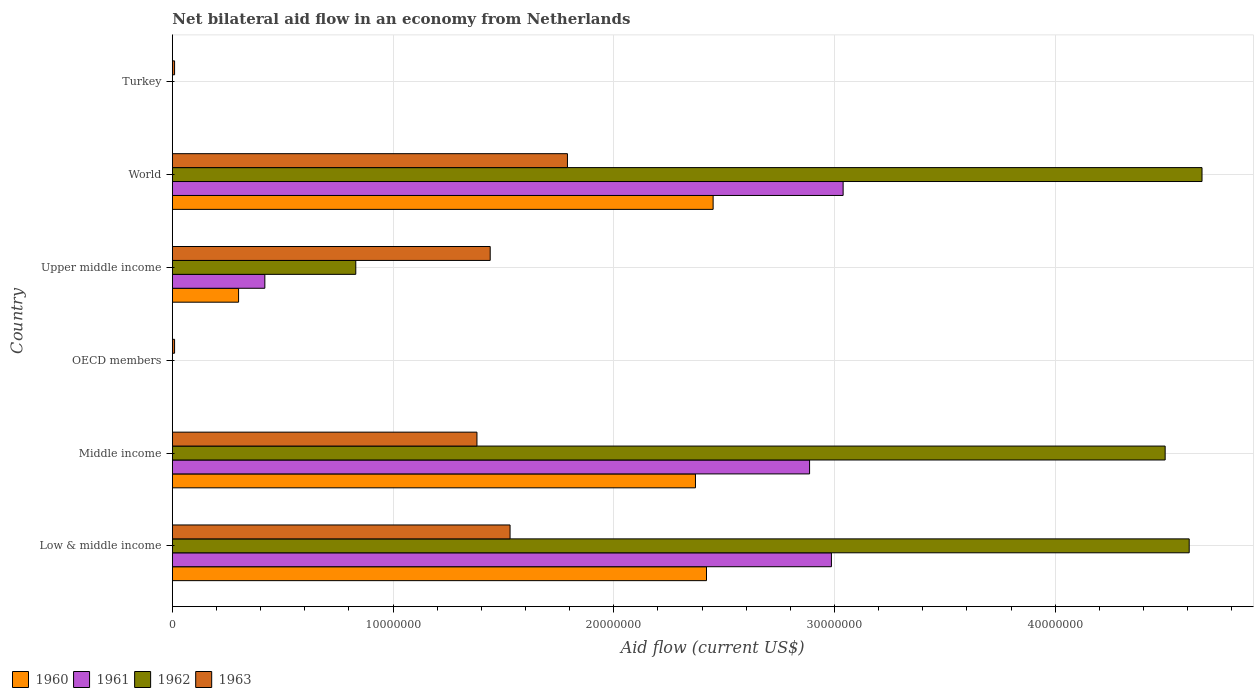How many different coloured bars are there?
Keep it short and to the point. 4. How many bars are there on the 2nd tick from the top?
Offer a very short reply. 4. How many bars are there on the 6th tick from the bottom?
Give a very brief answer. 1. What is the label of the 1st group of bars from the top?
Offer a terse response. Turkey. In how many cases, is the number of bars for a given country not equal to the number of legend labels?
Make the answer very short. 2. What is the net bilateral aid flow in 1962 in Middle income?
Give a very brief answer. 4.50e+07. Across all countries, what is the maximum net bilateral aid flow in 1960?
Provide a short and direct response. 2.45e+07. Across all countries, what is the minimum net bilateral aid flow in 1963?
Your answer should be compact. 1.00e+05. What is the total net bilateral aid flow in 1960 in the graph?
Provide a short and direct response. 7.54e+07. What is the difference between the net bilateral aid flow in 1962 in Middle income and the net bilateral aid flow in 1963 in World?
Your response must be concise. 2.71e+07. What is the average net bilateral aid flow in 1961 per country?
Your response must be concise. 1.56e+07. What is the difference between the net bilateral aid flow in 1961 and net bilateral aid flow in 1962 in World?
Your response must be concise. -1.63e+07. What is the ratio of the net bilateral aid flow in 1961 in Low & middle income to that in Middle income?
Ensure brevity in your answer.  1.03. Is the net bilateral aid flow in 1960 in Middle income less than that in Upper middle income?
Ensure brevity in your answer.  No. What is the difference between the highest and the lowest net bilateral aid flow in 1961?
Provide a succinct answer. 3.04e+07. In how many countries, is the net bilateral aid flow in 1960 greater than the average net bilateral aid flow in 1960 taken over all countries?
Your answer should be compact. 3. Is it the case that in every country, the sum of the net bilateral aid flow in 1963 and net bilateral aid flow in 1961 is greater than the net bilateral aid flow in 1962?
Your answer should be compact. No. How many bars are there?
Ensure brevity in your answer.  18. Are all the bars in the graph horizontal?
Keep it short and to the point. Yes. What is the difference between two consecutive major ticks on the X-axis?
Your response must be concise. 1.00e+07. Are the values on the major ticks of X-axis written in scientific E-notation?
Provide a short and direct response. No. What is the title of the graph?
Your response must be concise. Net bilateral aid flow in an economy from Netherlands. Does "1994" appear as one of the legend labels in the graph?
Offer a terse response. No. What is the label or title of the Y-axis?
Your answer should be very brief. Country. What is the Aid flow (current US$) in 1960 in Low & middle income?
Offer a terse response. 2.42e+07. What is the Aid flow (current US$) in 1961 in Low & middle income?
Keep it short and to the point. 2.99e+07. What is the Aid flow (current US$) of 1962 in Low & middle income?
Offer a very short reply. 4.61e+07. What is the Aid flow (current US$) of 1963 in Low & middle income?
Offer a terse response. 1.53e+07. What is the Aid flow (current US$) of 1960 in Middle income?
Make the answer very short. 2.37e+07. What is the Aid flow (current US$) of 1961 in Middle income?
Offer a terse response. 2.89e+07. What is the Aid flow (current US$) of 1962 in Middle income?
Provide a succinct answer. 4.50e+07. What is the Aid flow (current US$) of 1963 in Middle income?
Your response must be concise. 1.38e+07. What is the Aid flow (current US$) of 1963 in OECD members?
Offer a terse response. 1.00e+05. What is the Aid flow (current US$) of 1961 in Upper middle income?
Make the answer very short. 4.19e+06. What is the Aid flow (current US$) in 1962 in Upper middle income?
Provide a short and direct response. 8.31e+06. What is the Aid flow (current US$) in 1963 in Upper middle income?
Ensure brevity in your answer.  1.44e+07. What is the Aid flow (current US$) in 1960 in World?
Provide a succinct answer. 2.45e+07. What is the Aid flow (current US$) of 1961 in World?
Your answer should be compact. 3.04e+07. What is the Aid flow (current US$) in 1962 in World?
Offer a very short reply. 4.66e+07. What is the Aid flow (current US$) of 1963 in World?
Provide a succinct answer. 1.79e+07. What is the Aid flow (current US$) of 1960 in Turkey?
Give a very brief answer. 0. What is the Aid flow (current US$) of 1963 in Turkey?
Your response must be concise. 1.00e+05. Across all countries, what is the maximum Aid flow (current US$) in 1960?
Give a very brief answer. 2.45e+07. Across all countries, what is the maximum Aid flow (current US$) of 1961?
Give a very brief answer. 3.04e+07. Across all countries, what is the maximum Aid flow (current US$) in 1962?
Offer a terse response. 4.66e+07. Across all countries, what is the maximum Aid flow (current US$) in 1963?
Make the answer very short. 1.79e+07. Across all countries, what is the minimum Aid flow (current US$) in 1961?
Ensure brevity in your answer.  0. Across all countries, what is the minimum Aid flow (current US$) in 1962?
Offer a very short reply. 0. What is the total Aid flow (current US$) in 1960 in the graph?
Your response must be concise. 7.54e+07. What is the total Aid flow (current US$) of 1961 in the graph?
Make the answer very short. 9.33e+07. What is the total Aid flow (current US$) of 1962 in the graph?
Keep it short and to the point. 1.46e+08. What is the total Aid flow (current US$) of 1963 in the graph?
Provide a succinct answer. 6.16e+07. What is the difference between the Aid flow (current US$) in 1960 in Low & middle income and that in Middle income?
Provide a short and direct response. 5.00e+05. What is the difference between the Aid flow (current US$) of 1961 in Low & middle income and that in Middle income?
Provide a short and direct response. 9.90e+05. What is the difference between the Aid flow (current US$) in 1962 in Low & middle income and that in Middle income?
Your response must be concise. 1.09e+06. What is the difference between the Aid flow (current US$) of 1963 in Low & middle income and that in Middle income?
Make the answer very short. 1.50e+06. What is the difference between the Aid flow (current US$) in 1963 in Low & middle income and that in OECD members?
Your response must be concise. 1.52e+07. What is the difference between the Aid flow (current US$) of 1960 in Low & middle income and that in Upper middle income?
Your answer should be compact. 2.12e+07. What is the difference between the Aid flow (current US$) in 1961 in Low & middle income and that in Upper middle income?
Keep it short and to the point. 2.57e+07. What is the difference between the Aid flow (current US$) of 1962 in Low & middle income and that in Upper middle income?
Provide a short and direct response. 3.78e+07. What is the difference between the Aid flow (current US$) in 1963 in Low & middle income and that in Upper middle income?
Your answer should be compact. 9.00e+05. What is the difference between the Aid flow (current US$) in 1960 in Low & middle income and that in World?
Your answer should be compact. -3.00e+05. What is the difference between the Aid flow (current US$) of 1961 in Low & middle income and that in World?
Your answer should be very brief. -5.30e+05. What is the difference between the Aid flow (current US$) in 1962 in Low & middle income and that in World?
Offer a terse response. -5.80e+05. What is the difference between the Aid flow (current US$) in 1963 in Low & middle income and that in World?
Your answer should be compact. -2.60e+06. What is the difference between the Aid flow (current US$) of 1963 in Low & middle income and that in Turkey?
Offer a very short reply. 1.52e+07. What is the difference between the Aid flow (current US$) of 1963 in Middle income and that in OECD members?
Offer a terse response. 1.37e+07. What is the difference between the Aid flow (current US$) of 1960 in Middle income and that in Upper middle income?
Your response must be concise. 2.07e+07. What is the difference between the Aid flow (current US$) in 1961 in Middle income and that in Upper middle income?
Your answer should be very brief. 2.47e+07. What is the difference between the Aid flow (current US$) in 1962 in Middle income and that in Upper middle income?
Your answer should be very brief. 3.67e+07. What is the difference between the Aid flow (current US$) in 1963 in Middle income and that in Upper middle income?
Keep it short and to the point. -6.00e+05. What is the difference between the Aid flow (current US$) of 1960 in Middle income and that in World?
Ensure brevity in your answer.  -8.00e+05. What is the difference between the Aid flow (current US$) in 1961 in Middle income and that in World?
Offer a very short reply. -1.52e+06. What is the difference between the Aid flow (current US$) in 1962 in Middle income and that in World?
Ensure brevity in your answer.  -1.67e+06. What is the difference between the Aid flow (current US$) of 1963 in Middle income and that in World?
Your response must be concise. -4.10e+06. What is the difference between the Aid flow (current US$) in 1963 in Middle income and that in Turkey?
Your answer should be compact. 1.37e+07. What is the difference between the Aid flow (current US$) in 1963 in OECD members and that in Upper middle income?
Offer a terse response. -1.43e+07. What is the difference between the Aid flow (current US$) in 1963 in OECD members and that in World?
Ensure brevity in your answer.  -1.78e+07. What is the difference between the Aid flow (current US$) in 1963 in OECD members and that in Turkey?
Your answer should be very brief. 0. What is the difference between the Aid flow (current US$) in 1960 in Upper middle income and that in World?
Keep it short and to the point. -2.15e+07. What is the difference between the Aid flow (current US$) in 1961 in Upper middle income and that in World?
Your answer should be very brief. -2.62e+07. What is the difference between the Aid flow (current US$) of 1962 in Upper middle income and that in World?
Offer a terse response. -3.83e+07. What is the difference between the Aid flow (current US$) in 1963 in Upper middle income and that in World?
Keep it short and to the point. -3.50e+06. What is the difference between the Aid flow (current US$) of 1963 in Upper middle income and that in Turkey?
Provide a succinct answer. 1.43e+07. What is the difference between the Aid flow (current US$) in 1963 in World and that in Turkey?
Give a very brief answer. 1.78e+07. What is the difference between the Aid flow (current US$) of 1960 in Low & middle income and the Aid flow (current US$) of 1961 in Middle income?
Provide a short and direct response. -4.67e+06. What is the difference between the Aid flow (current US$) of 1960 in Low & middle income and the Aid flow (current US$) of 1962 in Middle income?
Ensure brevity in your answer.  -2.08e+07. What is the difference between the Aid flow (current US$) of 1960 in Low & middle income and the Aid flow (current US$) of 1963 in Middle income?
Make the answer very short. 1.04e+07. What is the difference between the Aid flow (current US$) of 1961 in Low & middle income and the Aid flow (current US$) of 1962 in Middle income?
Provide a short and direct response. -1.51e+07. What is the difference between the Aid flow (current US$) in 1961 in Low & middle income and the Aid flow (current US$) in 1963 in Middle income?
Offer a very short reply. 1.61e+07. What is the difference between the Aid flow (current US$) of 1962 in Low & middle income and the Aid flow (current US$) of 1963 in Middle income?
Ensure brevity in your answer.  3.23e+07. What is the difference between the Aid flow (current US$) of 1960 in Low & middle income and the Aid flow (current US$) of 1963 in OECD members?
Make the answer very short. 2.41e+07. What is the difference between the Aid flow (current US$) of 1961 in Low & middle income and the Aid flow (current US$) of 1963 in OECD members?
Offer a terse response. 2.98e+07. What is the difference between the Aid flow (current US$) of 1962 in Low & middle income and the Aid flow (current US$) of 1963 in OECD members?
Keep it short and to the point. 4.60e+07. What is the difference between the Aid flow (current US$) in 1960 in Low & middle income and the Aid flow (current US$) in 1961 in Upper middle income?
Keep it short and to the point. 2.00e+07. What is the difference between the Aid flow (current US$) of 1960 in Low & middle income and the Aid flow (current US$) of 1962 in Upper middle income?
Provide a succinct answer. 1.59e+07. What is the difference between the Aid flow (current US$) in 1960 in Low & middle income and the Aid flow (current US$) in 1963 in Upper middle income?
Ensure brevity in your answer.  9.80e+06. What is the difference between the Aid flow (current US$) in 1961 in Low & middle income and the Aid flow (current US$) in 1962 in Upper middle income?
Your response must be concise. 2.16e+07. What is the difference between the Aid flow (current US$) of 1961 in Low & middle income and the Aid flow (current US$) of 1963 in Upper middle income?
Ensure brevity in your answer.  1.55e+07. What is the difference between the Aid flow (current US$) of 1962 in Low & middle income and the Aid flow (current US$) of 1963 in Upper middle income?
Give a very brief answer. 3.17e+07. What is the difference between the Aid flow (current US$) of 1960 in Low & middle income and the Aid flow (current US$) of 1961 in World?
Keep it short and to the point. -6.19e+06. What is the difference between the Aid flow (current US$) of 1960 in Low & middle income and the Aid flow (current US$) of 1962 in World?
Give a very brief answer. -2.24e+07. What is the difference between the Aid flow (current US$) in 1960 in Low & middle income and the Aid flow (current US$) in 1963 in World?
Make the answer very short. 6.30e+06. What is the difference between the Aid flow (current US$) in 1961 in Low & middle income and the Aid flow (current US$) in 1962 in World?
Your answer should be very brief. -1.68e+07. What is the difference between the Aid flow (current US$) in 1961 in Low & middle income and the Aid flow (current US$) in 1963 in World?
Ensure brevity in your answer.  1.20e+07. What is the difference between the Aid flow (current US$) of 1962 in Low & middle income and the Aid flow (current US$) of 1963 in World?
Provide a short and direct response. 2.82e+07. What is the difference between the Aid flow (current US$) in 1960 in Low & middle income and the Aid flow (current US$) in 1963 in Turkey?
Give a very brief answer. 2.41e+07. What is the difference between the Aid flow (current US$) in 1961 in Low & middle income and the Aid flow (current US$) in 1963 in Turkey?
Give a very brief answer. 2.98e+07. What is the difference between the Aid flow (current US$) in 1962 in Low & middle income and the Aid flow (current US$) in 1963 in Turkey?
Make the answer very short. 4.60e+07. What is the difference between the Aid flow (current US$) of 1960 in Middle income and the Aid flow (current US$) of 1963 in OECD members?
Make the answer very short. 2.36e+07. What is the difference between the Aid flow (current US$) in 1961 in Middle income and the Aid flow (current US$) in 1963 in OECD members?
Offer a terse response. 2.88e+07. What is the difference between the Aid flow (current US$) of 1962 in Middle income and the Aid flow (current US$) of 1963 in OECD members?
Your answer should be compact. 4.49e+07. What is the difference between the Aid flow (current US$) in 1960 in Middle income and the Aid flow (current US$) in 1961 in Upper middle income?
Provide a short and direct response. 1.95e+07. What is the difference between the Aid flow (current US$) of 1960 in Middle income and the Aid flow (current US$) of 1962 in Upper middle income?
Your answer should be compact. 1.54e+07. What is the difference between the Aid flow (current US$) in 1960 in Middle income and the Aid flow (current US$) in 1963 in Upper middle income?
Your answer should be very brief. 9.30e+06. What is the difference between the Aid flow (current US$) in 1961 in Middle income and the Aid flow (current US$) in 1962 in Upper middle income?
Give a very brief answer. 2.06e+07. What is the difference between the Aid flow (current US$) of 1961 in Middle income and the Aid flow (current US$) of 1963 in Upper middle income?
Your response must be concise. 1.45e+07. What is the difference between the Aid flow (current US$) of 1962 in Middle income and the Aid flow (current US$) of 1963 in Upper middle income?
Give a very brief answer. 3.06e+07. What is the difference between the Aid flow (current US$) in 1960 in Middle income and the Aid flow (current US$) in 1961 in World?
Provide a succinct answer. -6.69e+06. What is the difference between the Aid flow (current US$) of 1960 in Middle income and the Aid flow (current US$) of 1962 in World?
Ensure brevity in your answer.  -2.30e+07. What is the difference between the Aid flow (current US$) in 1960 in Middle income and the Aid flow (current US$) in 1963 in World?
Offer a terse response. 5.80e+06. What is the difference between the Aid flow (current US$) in 1961 in Middle income and the Aid flow (current US$) in 1962 in World?
Keep it short and to the point. -1.78e+07. What is the difference between the Aid flow (current US$) in 1961 in Middle income and the Aid flow (current US$) in 1963 in World?
Give a very brief answer. 1.10e+07. What is the difference between the Aid flow (current US$) in 1962 in Middle income and the Aid flow (current US$) in 1963 in World?
Your answer should be very brief. 2.71e+07. What is the difference between the Aid flow (current US$) of 1960 in Middle income and the Aid flow (current US$) of 1963 in Turkey?
Your answer should be compact. 2.36e+07. What is the difference between the Aid flow (current US$) of 1961 in Middle income and the Aid flow (current US$) of 1963 in Turkey?
Your answer should be compact. 2.88e+07. What is the difference between the Aid flow (current US$) of 1962 in Middle income and the Aid flow (current US$) of 1963 in Turkey?
Your response must be concise. 4.49e+07. What is the difference between the Aid flow (current US$) in 1960 in Upper middle income and the Aid flow (current US$) in 1961 in World?
Provide a short and direct response. -2.74e+07. What is the difference between the Aid flow (current US$) of 1960 in Upper middle income and the Aid flow (current US$) of 1962 in World?
Your answer should be compact. -4.36e+07. What is the difference between the Aid flow (current US$) of 1960 in Upper middle income and the Aid flow (current US$) of 1963 in World?
Provide a succinct answer. -1.49e+07. What is the difference between the Aid flow (current US$) of 1961 in Upper middle income and the Aid flow (current US$) of 1962 in World?
Make the answer very short. -4.25e+07. What is the difference between the Aid flow (current US$) in 1961 in Upper middle income and the Aid flow (current US$) in 1963 in World?
Provide a succinct answer. -1.37e+07. What is the difference between the Aid flow (current US$) in 1962 in Upper middle income and the Aid flow (current US$) in 1963 in World?
Your answer should be very brief. -9.59e+06. What is the difference between the Aid flow (current US$) of 1960 in Upper middle income and the Aid flow (current US$) of 1963 in Turkey?
Make the answer very short. 2.90e+06. What is the difference between the Aid flow (current US$) of 1961 in Upper middle income and the Aid flow (current US$) of 1963 in Turkey?
Provide a succinct answer. 4.09e+06. What is the difference between the Aid flow (current US$) in 1962 in Upper middle income and the Aid flow (current US$) in 1963 in Turkey?
Your response must be concise. 8.21e+06. What is the difference between the Aid flow (current US$) of 1960 in World and the Aid flow (current US$) of 1963 in Turkey?
Your response must be concise. 2.44e+07. What is the difference between the Aid flow (current US$) of 1961 in World and the Aid flow (current US$) of 1963 in Turkey?
Offer a terse response. 3.03e+07. What is the difference between the Aid flow (current US$) in 1962 in World and the Aid flow (current US$) in 1963 in Turkey?
Ensure brevity in your answer.  4.66e+07. What is the average Aid flow (current US$) in 1960 per country?
Provide a succinct answer. 1.26e+07. What is the average Aid flow (current US$) of 1961 per country?
Give a very brief answer. 1.56e+07. What is the average Aid flow (current US$) of 1962 per country?
Provide a succinct answer. 2.43e+07. What is the average Aid flow (current US$) of 1963 per country?
Your response must be concise. 1.03e+07. What is the difference between the Aid flow (current US$) in 1960 and Aid flow (current US$) in 1961 in Low & middle income?
Provide a short and direct response. -5.66e+06. What is the difference between the Aid flow (current US$) in 1960 and Aid flow (current US$) in 1962 in Low & middle income?
Your answer should be compact. -2.19e+07. What is the difference between the Aid flow (current US$) of 1960 and Aid flow (current US$) of 1963 in Low & middle income?
Make the answer very short. 8.90e+06. What is the difference between the Aid flow (current US$) in 1961 and Aid flow (current US$) in 1962 in Low & middle income?
Your response must be concise. -1.62e+07. What is the difference between the Aid flow (current US$) of 1961 and Aid flow (current US$) of 1963 in Low & middle income?
Give a very brief answer. 1.46e+07. What is the difference between the Aid flow (current US$) in 1962 and Aid flow (current US$) in 1963 in Low & middle income?
Provide a succinct answer. 3.08e+07. What is the difference between the Aid flow (current US$) in 1960 and Aid flow (current US$) in 1961 in Middle income?
Your answer should be very brief. -5.17e+06. What is the difference between the Aid flow (current US$) of 1960 and Aid flow (current US$) of 1962 in Middle income?
Keep it short and to the point. -2.13e+07. What is the difference between the Aid flow (current US$) of 1960 and Aid flow (current US$) of 1963 in Middle income?
Provide a succinct answer. 9.90e+06. What is the difference between the Aid flow (current US$) of 1961 and Aid flow (current US$) of 1962 in Middle income?
Provide a succinct answer. -1.61e+07. What is the difference between the Aid flow (current US$) of 1961 and Aid flow (current US$) of 1963 in Middle income?
Offer a terse response. 1.51e+07. What is the difference between the Aid flow (current US$) of 1962 and Aid flow (current US$) of 1963 in Middle income?
Your answer should be compact. 3.12e+07. What is the difference between the Aid flow (current US$) in 1960 and Aid flow (current US$) in 1961 in Upper middle income?
Provide a short and direct response. -1.19e+06. What is the difference between the Aid flow (current US$) of 1960 and Aid flow (current US$) of 1962 in Upper middle income?
Provide a succinct answer. -5.31e+06. What is the difference between the Aid flow (current US$) of 1960 and Aid flow (current US$) of 1963 in Upper middle income?
Your answer should be compact. -1.14e+07. What is the difference between the Aid flow (current US$) of 1961 and Aid flow (current US$) of 1962 in Upper middle income?
Your answer should be compact. -4.12e+06. What is the difference between the Aid flow (current US$) of 1961 and Aid flow (current US$) of 1963 in Upper middle income?
Your answer should be compact. -1.02e+07. What is the difference between the Aid flow (current US$) of 1962 and Aid flow (current US$) of 1963 in Upper middle income?
Provide a short and direct response. -6.09e+06. What is the difference between the Aid flow (current US$) of 1960 and Aid flow (current US$) of 1961 in World?
Ensure brevity in your answer.  -5.89e+06. What is the difference between the Aid flow (current US$) of 1960 and Aid flow (current US$) of 1962 in World?
Offer a very short reply. -2.22e+07. What is the difference between the Aid flow (current US$) of 1960 and Aid flow (current US$) of 1963 in World?
Your answer should be very brief. 6.60e+06. What is the difference between the Aid flow (current US$) of 1961 and Aid flow (current US$) of 1962 in World?
Your response must be concise. -1.63e+07. What is the difference between the Aid flow (current US$) of 1961 and Aid flow (current US$) of 1963 in World?
Keep it short and to the point. 1.25e+07. What is the difference between the Aid flow (current US$) of 1962 and Aid flow (current US$) of 1963 in World?
Your answer should be compact. 2.88e+07. What is the ratio of the Aid flow (current US$) of 1960 in Low & middle income to that in Middle income?
Provide a short and direct response. 1.02. What is the ratio of the Aid flow (current US$) of 1961 in Low & middle income to that in Middle income?
Your response must be concise. 1.03. What is the ratio of the Aid flow (current US$) in 1962 in Low & middle income to that in Middle income?
Keep it short and to the point. 1.02. What is the ratio of the Aid flow (current US$) in 1963 in Low & middle income to that in Middle income?
Give a very brief answer. 1.11. What is the ratio of the Aid flow (current US$) of 1963 in Low & middle income to that in OECD members?
Provide a short and direct response. 153. What is the ratio of the Aid flow (current US$) of 1960 in Low & middle income to that in Upper middle income?
Your answer should be compact. 8.07. What is the ratio of the Aid flow (current US$) of 1961 in Low & middle income to that in Upper middle income?
Provide a short and direct response. 7.13. What is the ratio of the Aid flow (current US$) in 1962 in Low & middle income to that in Upper middle income?
Your answer should be compact. 5.54. What is the ratio of the Aid flow (current US$) of 1963 in Low & middle income to that in Upper middle income?
Make the answer very short. 1.06. What is the ratio of the Aid flow (current US$) in 1960 in Low & middle income to that in World?
Keep it short and to the point. 0.99. What is the ratio of the Aid flow (current US$) of 1961 in Low & middle income to that in World?
Ensure brevity in your answer.  0.98. What is the ratio of the Aid flow (current US$) in 1962 in Low & middle income to that in World?
Offer a terse response. 0.99. What is the ratio of the Aid flow (current US$) in 1963 in Low & middle income to that in World?
Provide a short and direct response. 0.85. What is the ratio of the Aid flow (current US$) in 1963 in Low & middle income to that in Turkey?
Offer a very short reply. 153. What is the ratio of the Aid flow (current US$) of 1963 in Middle income to that in OECD members?
Your answer should be compact. 138. What is the ratio of the Aid flow (current US$) of 1960 in Middle income to that in Upper middle income?
Make the answer very short. 7.9. What is the ratio of the Aid flow (current US$) of 1961 in Middle income to that in Upper middle income?
Your answer should be compact. 6.89. What is the ratio of the Aid flow (current US$) of 1962 in Middle income to that in Upper middle income?
Ensure brevity in your answer.  5.41. What is the ratio of the Aid flow (current US$) in 1960 in Middle income to that in World?
Give a very brief answer. 0.97. What is the ratio of the Aid flow (current US$) of 1962 in Middle income to that in World?
Ensure brevity in your answer.  0.96. What is the ratio of the Aid flow (current US$) in 1963 in Middle income to that in World?
Keep it short and to the point. 0.77. What is the ratio of the Aid flow (current US$) of 1963 in Middle income to that in Turkey?
Your answer should be compact. 138. What is the ratio of the Aid flow (current US$) in 1963 in OECD members to that in Upper middle income?
Provide a short and direct response. 0.01. What is the ratio of the Aid flow (current US$) in 1963 in OECD members to that in World?
Your response must be concise. 0.01. What is the ratio of the Aid flow (current US$) in 1960 in Upper middle income to that in World?
Give a very brief answer. 0.12. What is the ratio of the Aid flow (current US$) of 1961 in Upper middle income to that in World?
Provide a short and direct response. 0.14. What is the ratio of the Aid flow (current US$) in 1962 in Upper middle income to that in World?
Provide a short and direct response. 0.18. What is the ratio of the Aid flow (current US$) in 1963 in Upper middle income to that in World?
Make the answer very short. 0.8. What is the ratio of the Aid flow (current US$) of 1963 in Upper middle income to that in Turkey?
Provide a short and direct response. 144. What is the ratio of the Aid flow (current US$) in 1963 in World to that in Turkey?
Your answer should be compact. 179. What is the difference between the highest and the second highest Aid flow (current US$) of 1961?
Ensure brevity in your answer.  5.30e+05. What is the difference between the highest and the second highest Aid flow (current US$) of 1962?
Provide a short and direct response. 5.80e+05. What is the difference between the highest and the second highest Aid flow (current US$) of 1963?
Make the answer very short. 2.60e+06. What is the difference between the highest and the lowest Aid flow (current US$) of 1960?
Give a very brief answer. 2.45e+07. What is the difference between the highest and the lowest Aid flow (current US$) of 1961?
Keep it short and to the point. 3.04e+07. What is the difference between the highest and the lowest Aid flow (current US$) in 1962?
Your response must be concise. 4.66e+07. What is the difference between the highest and the lowest Aid flow (current US$) of 1963?
Make the answer very short. 1.78e+07. 